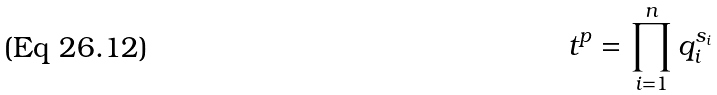<formula> <loc_0><loc_0><loc_500><loc_500>t ^ { p } = \prod _ { i = 1 } ^ { n } q _ { i } ^ { s _ { i } }</formula> 